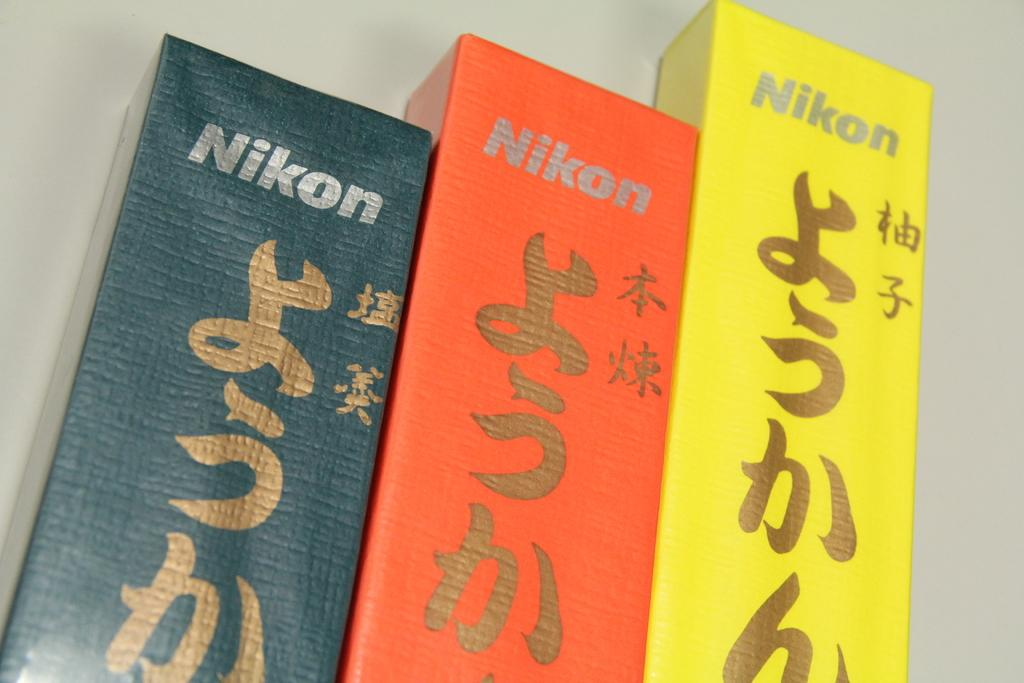<image>
Offer a succinct explanation of the picture presented. The three books with foreign writing are by Nikon. 